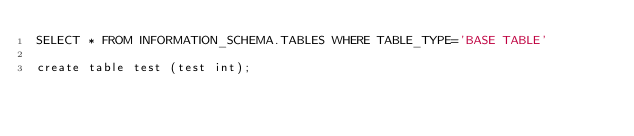<code> <loc_0><loc_0><loc_500><loc_500><_SQL_>SELECT * FROM INFORMATION_SCHEMA.TABLES WHERE TABLE_TYPE='BASE TABLE'

create table test (test int);</code> 